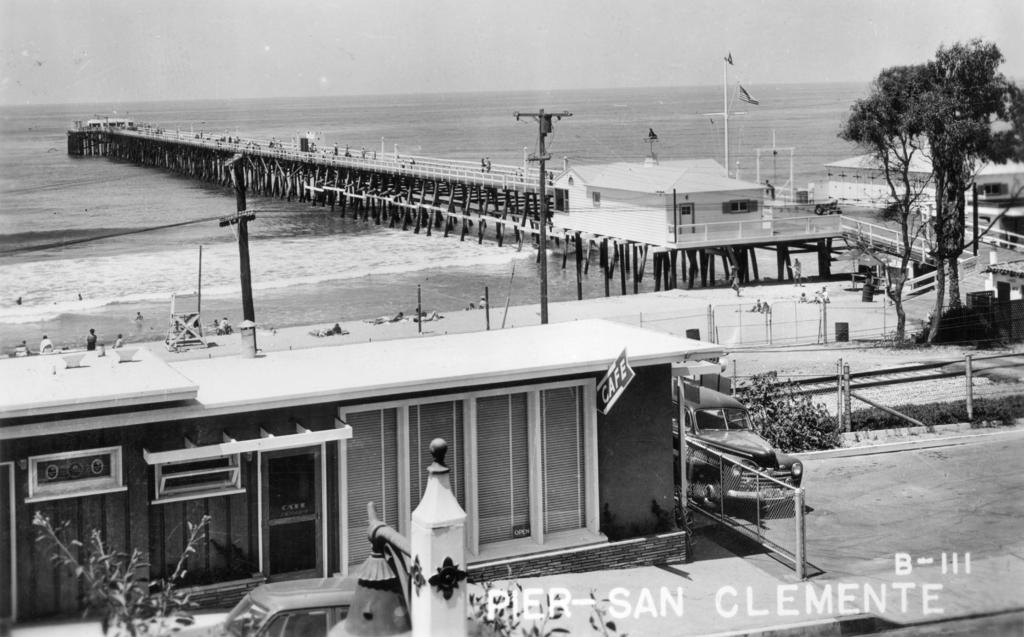What type of structure is visible in the image? There is a building in the image. What natural feature can be seen in the image? There is an ocean in the image. What are the people doing in the image? The people are lying on the sand in the image. What type of plant is present in the image? There is a tree in the image. What man-made structure can be seen in the image? There is a bridge in the image. What type of voice can be heard coming from the ocean in the image? There is no voice present in the image; it is a visual representation without any sound. How many pizzas are visible on the sand in the image? There are no pizzas present in the image; the people are lying on the sand. What type of animal is sitting on the bridge in the image? There is no animal, specifically a squirrel, present on the bridge or in the image. 